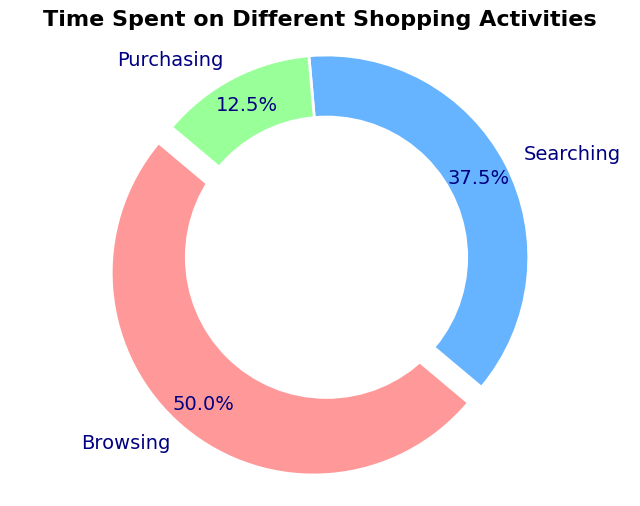What's the total amount of time spent on shopping activities? There are three activities: Browsing, Searching, and Purchasing. The time spent on each is 120 minutes, 90 minutes, and 30 minutes, respectively. Summing these up: 120 + 90 + 30 = 240 minutes.
Answer: 240 minutes Which activity took the least amount of time? Looking at the slices of the pie chart, the smallest segment corresponds to Purchasing. The time spent on Purchasing is 30 minutes, which is less than Browsing (120 minutes) and Searching (90 minutes).
Answer: Purchasing What percentage of time is spent on Browsing? The pie chart shows the percentage of time spent on each activity. Browsing occupies a prominent portion and is explicitly labeled with its percentage. According to the chart, Browsing takes 53.6% of the time.
Answer: 53.6% How does the time spent on Searching compare to the time spent on Purchasing? According to the pie chart, the time spent on Searching is 90 minutes, while the time spent on Purchasing is 30 minutes. Searching takes more time than Purchasing. Specifically, 90 minutes is three times 30 minutes.
Answer: Searching takes 3 times as long as Purchasing What is the combined percentage of total time spent on Browsing and Purchasing? The pie chart provides the percentages for Browsing and Purchasing as 53.6% and 12.5%, respectively. Adding these together: 53.6% + 12.5% = 66.1%.
Answer: 66.1% Which color is used to represent the Purchasing activity? The pie chart uses different colors for each activity: one for Browsing, one for Searching, and one for Purchasing. The smallest segment representing Purchasing is colored in light green.
Answer: Light green By how many minutes does the time spent Browsing exceed the time spent Searching? The time spent on Browsing is 120 minutes and on Searching is 90 minutes. Subtracting these gives the difference: 120 - 90 = 30 minutes.
Answer: 30 minutes What fraction and percentage of total time is spent on Searching? The time spent on Searching is 90 minutes out of the total time of 240 minutes. The fraction of time spent on Searching is 90/240 = 3/8. As a percentage: (90/240) * 100 = 37.5%.
Answer: 3/8 and 37.5% What activity is represented by the exploded slice in the pie chart? The pie chart has one slice that is slightly separated or "exploded" from the rest. This design choice highlights the activity which is Browsing.
Answer: Browsing 